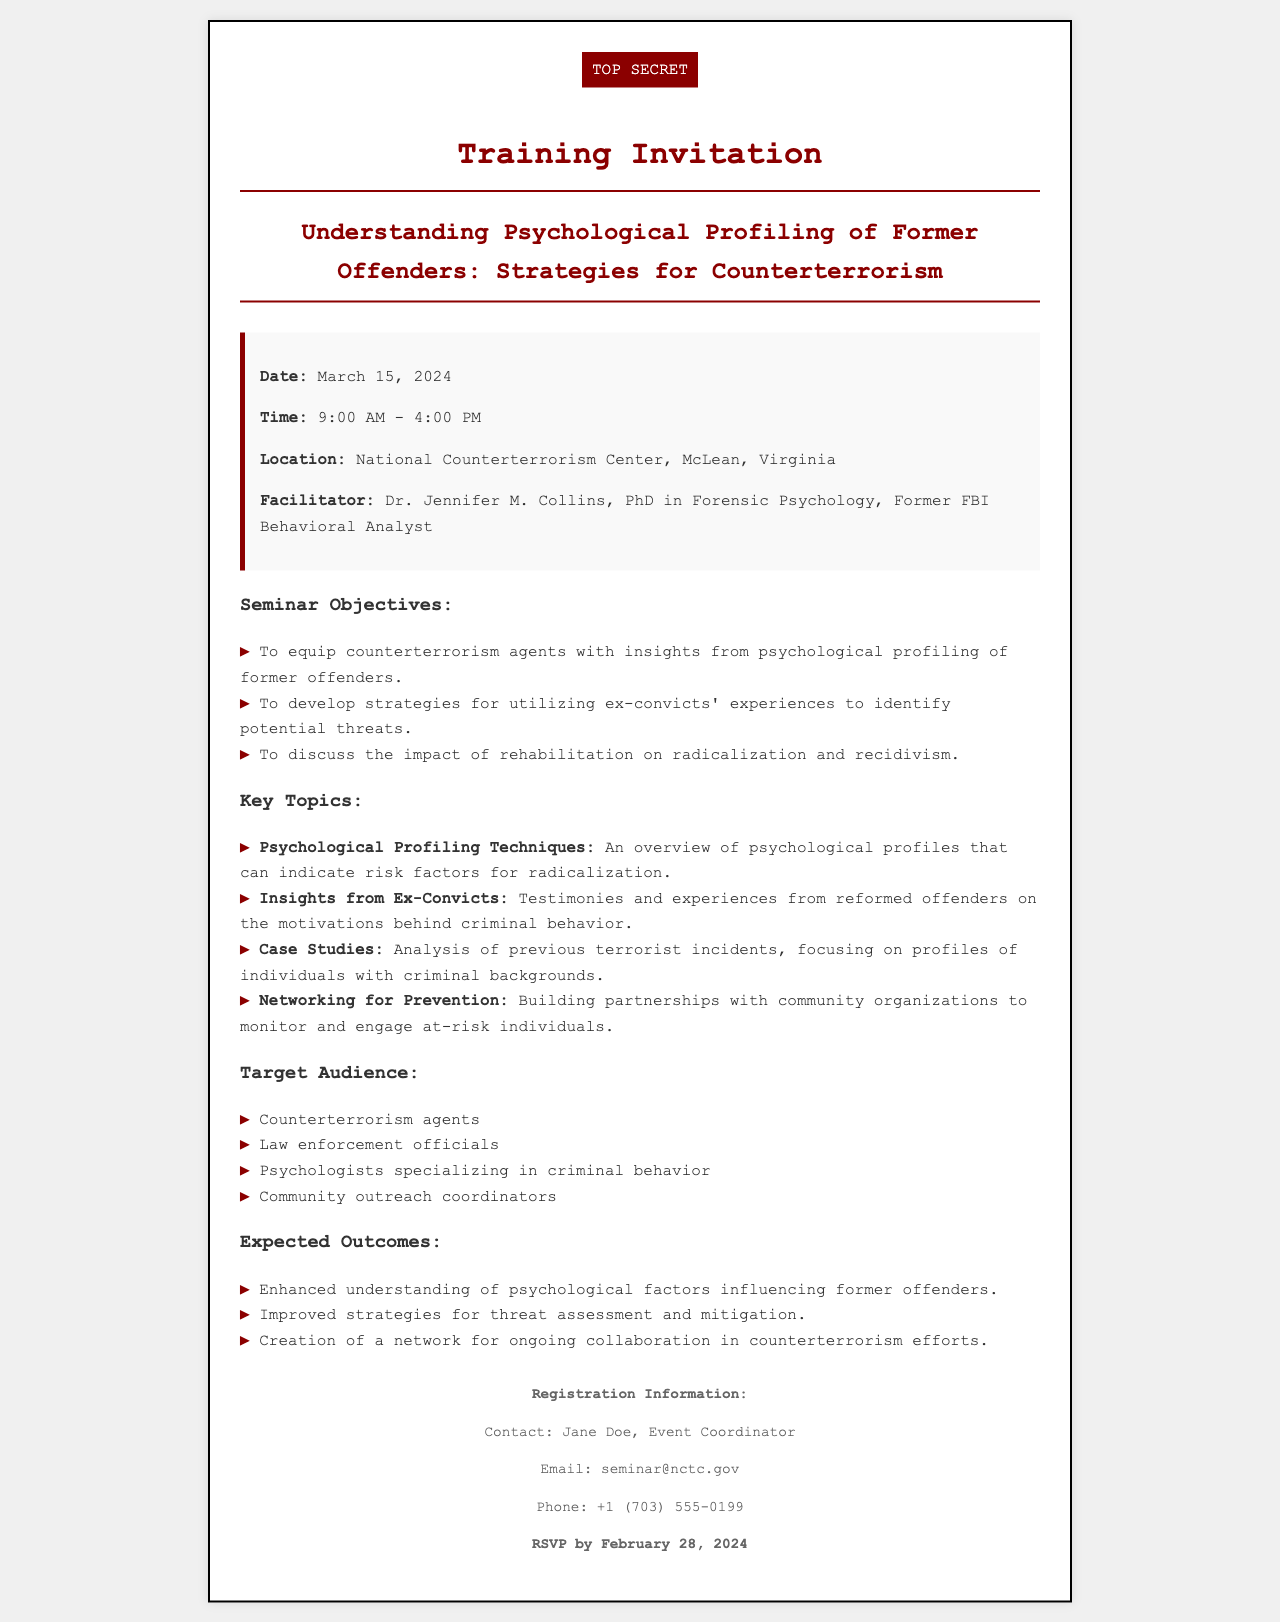What is the date of the seminar? The date of the seminar is mentioned clearly in the details section of the document.
Answer: March 15, 2024 Who is the facilitator of the seminar? The document specifies Dr. Jennifer M. Collins as the facilitator along with her qualifications.
Answer: Dr. Jennifer M. Collins What time does the seminar start? The starting time of the seminar is listed in the details section.
Answer: 9:00 AM What is one of the key topics discussed in the seminar? The document provides a list of key topics, one of which can be identified from that list.
Answer: Psychological Profiling Techniques What is the RSVP deadline for the seminar? The RSVP deadline is explicitly stated in the footer section of the document.
Answer: February 28, 2024 What is the location of the seminar? The location is provided in the details section of the invitation document.
Answer: National Counterterrorism Center, McLean, Virginia Who should attend this seminar? The document outlines the target audience for the seminar, highlighting several specific groups.
Answer: Counterterrorism agents What is one expected outcome of the seminar? The expected outcomes are listed, and any of them can serve as an answer.
Answer: Enhanced understanding of psychological factors influencing former offenders What type of psychological professional is mentioned in the target audience? The document lists various professionals expected to attend, one being psychologists.
Answer: Psychologists specializing in criminal behavior 